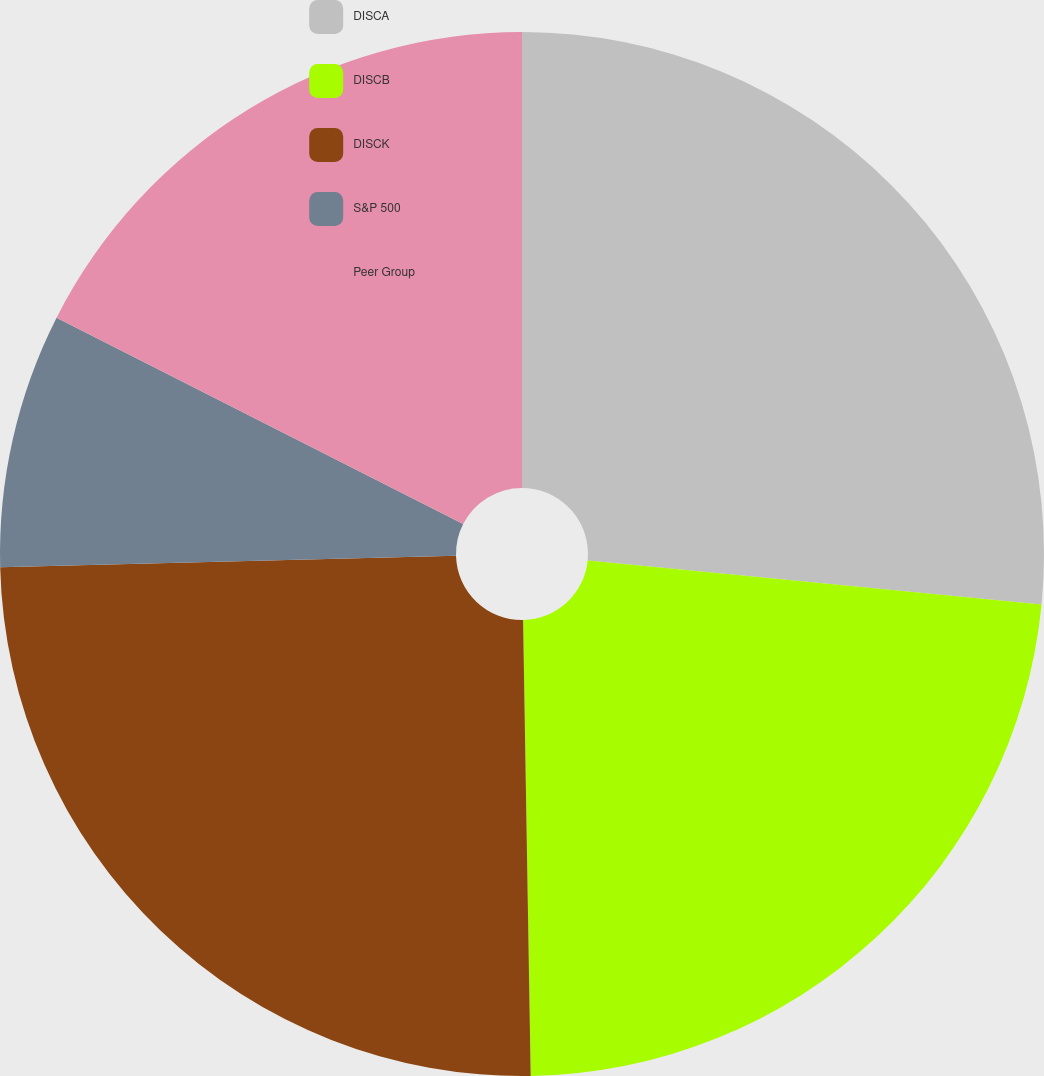Convert chart. <chart><loc_0><loc_0><loc_500><loc_500><pie_chart><fcel>DISCA<fcel>DISCB<fcel>DISCK<fcel>S&P 500<fcel>Peer Group<nl><fcel>26.54%<fcel>23.19%<fcel>24.86%<fcel>7.88%<fcel>17.52%<nl></chart> 